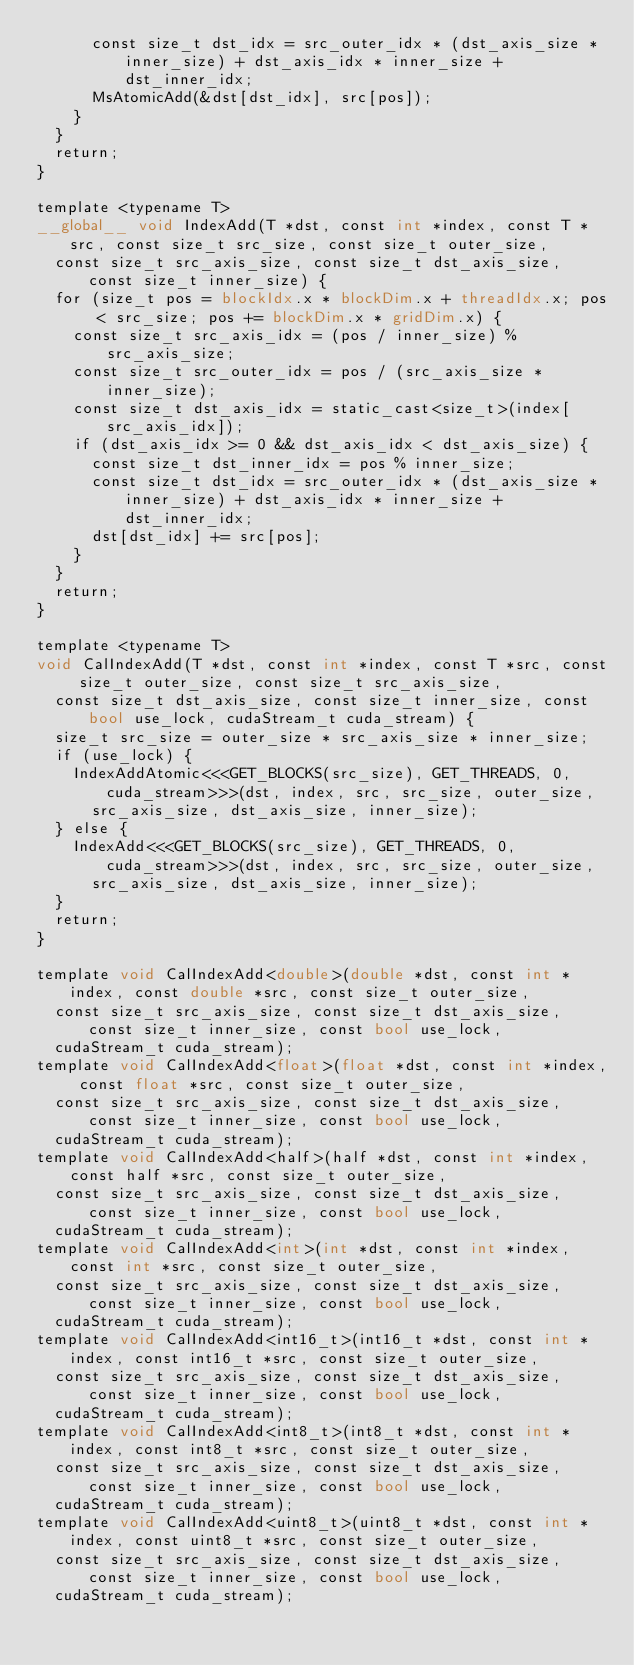Convert code to text. <code><loc_0><loc_0><loc_500><loc_500><_Cuda_>      const size_t dst_idx = src_outer_idx * (dst_axis_size * inner_size) + dst_axis_idx * inner_size + dst_inner_idx;
      MsAtomicAdd(&dst[dst_idx], src[pos]);
    }
  }
  return;
}

template <typename T>
__global__ void IndexAdd(T *dst, const int *index, const T *src, const size_t src_size, const size_t outer_size,
  const size_t src_axis_size, const size_t dst_axis_size, const size_t inner_size) {
  for (size_t pos = blockIdx.x * blockDim.x + threadIdx.x; pos < src_size; pos += blockDim.x * gridDim.x) {
    const size_t src_axis_idx = (pos / inner_size) % src_axis_size;
    const size_t src_outer_idx = pos / (src_axis_size * inner_size);
    const size_t dst_axis_idx = static_cast<size_t>(index[src_axis_idx]);
    if (dst_axis_idx >= 0 && dst_axis_idx < dst_axis_size) {
      const size_t dst_inner_idx = pos % inner_size;
      const size_t dst_idx = src_outer_idx * (dst_axis_size * inner_size) + dst_axis_idx * inner_size + dst_inner_idx;
      dst[dst_idx] += src[pos];
    }
  }
  return;
}

template <typename T>
void CalIndexAdd(T *dst, const int *index, const T *src, const size_t outer_size, const size_t src_axis_size,
  const size_t dst_axis_size, const size_t inner_size, const bool use_lock, cudaStream_t cuda_stream) {
  size_t src_size = outer_size * src_axis_size * inner_size;
  if (use_lock) {
    IndexAddAtomic<<<GET_BLOCKS(src_size), GET_THREADS, 0, cuda_stream>>>(dst, index, src, src_size, outer_size,
      src_axis_size, dst_axis_size, inner_size);
  } else {
    IndexAdd<<<GET_BLOCKS(src_size), GET_THREADS, 0, cuda_stream>>>(dst, index, src, src_size, outer_size,
      src_axis_size, dst_axis_size, inner_size);
  }
  return;
}

template void CalIndexAdd<double>(double *dst, const int *index, const double *src, const size_t outer_size,
  const size_t src_axis_size, const size_t dst_axis_size, const size_t inner_size, const bool use_lock,
  cudaStream_t cuda_stream);
template void CalIndexAdd<float>(float *dst, const int *index, const float *src, const size_t outer_size,
  const size_t src_axis_size, const size_t dst_axis_size, const size_t inner_size, const bool use_lock,
  cudaStream_t cuda_stream);
template void CalIndexAdd<half>(half *dst, const int *index, const half *src, const size_t outer_size,
  const size_t src_axis_size, const size_t dst_axis_size, const size_t inner_size, const bool use_lock,
  cudaStream_t cuda_stream);
template void CalIndexAdd<int>(int *dst, const int *index, const int *src, const size_t outer_size,
  const size_t src_axis_size, const size_t dst_axis_size, const size_t inner_size, const bool use_lock,
  cudaStream_t cuda_stream);
template void CalIndexAdd<int16_t>(int16_t *dst, const int *index, const int16_t *src, const size_t outer_size,
  const size_t src_axis_size, const size_t dst_axis_size, const size_t inner_size, const bool use_lock,
  cudaStream_t cuda_stream);
template void CalIndexAdd<int8_t>(int8_t *dst, const int *index, const int8_t *src, const size_t outer_size,
  const size_t src_axis_size, const size_t dst_axis_size, const size_t inner_size, const bool use_lock,
  cudaStream_t cuda_stream);
template void CalIndexAdd<uint8_t>(uint8_t *dst, const int *index, const uint8_t *src, const size_t outer_size,
  const size_t src_axis_size, const size_t dst_axis_size, const size_t inner_size, const bool use_lock,
  cudaStream_t cuda_stream);
</code> 